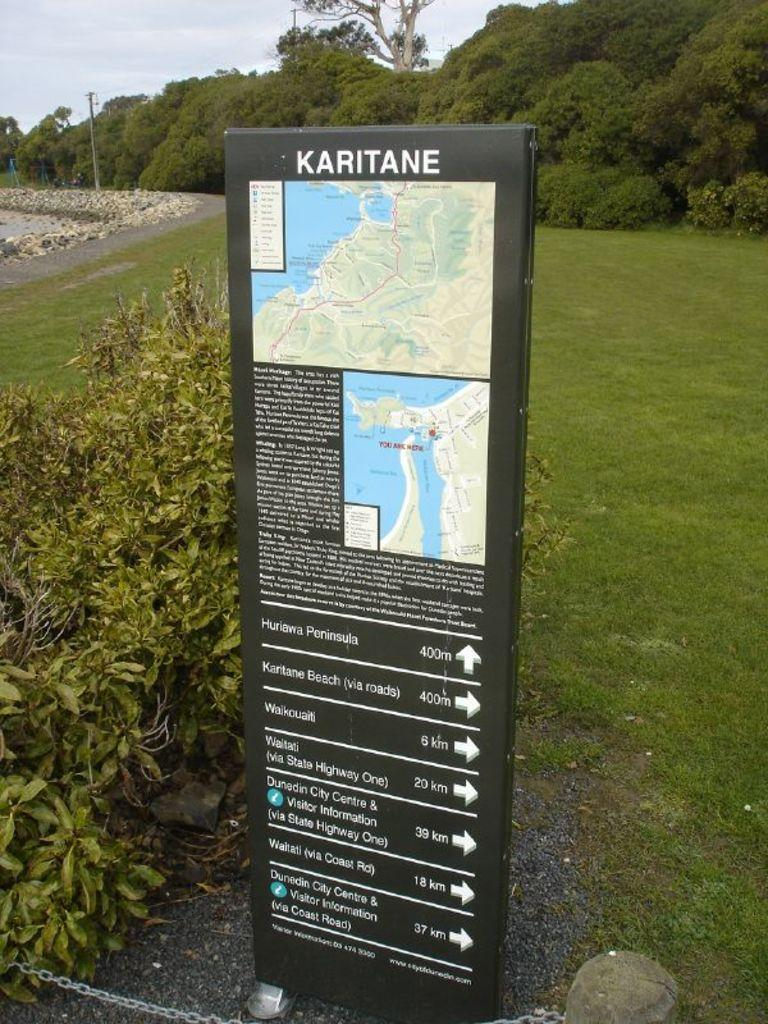What is the main object in the image? There is a route map board in the image. What type of natural environment is visible in the image? There is grass, plants, rocks, trees, and the sky visible in the image. Can you describe the pole in the background of the image? There is a pole in the background of the image, but no specific details about it are provided. What type of thread is being used to create the print on the wax in the image? There is no thread, wax, or print present in the image. 